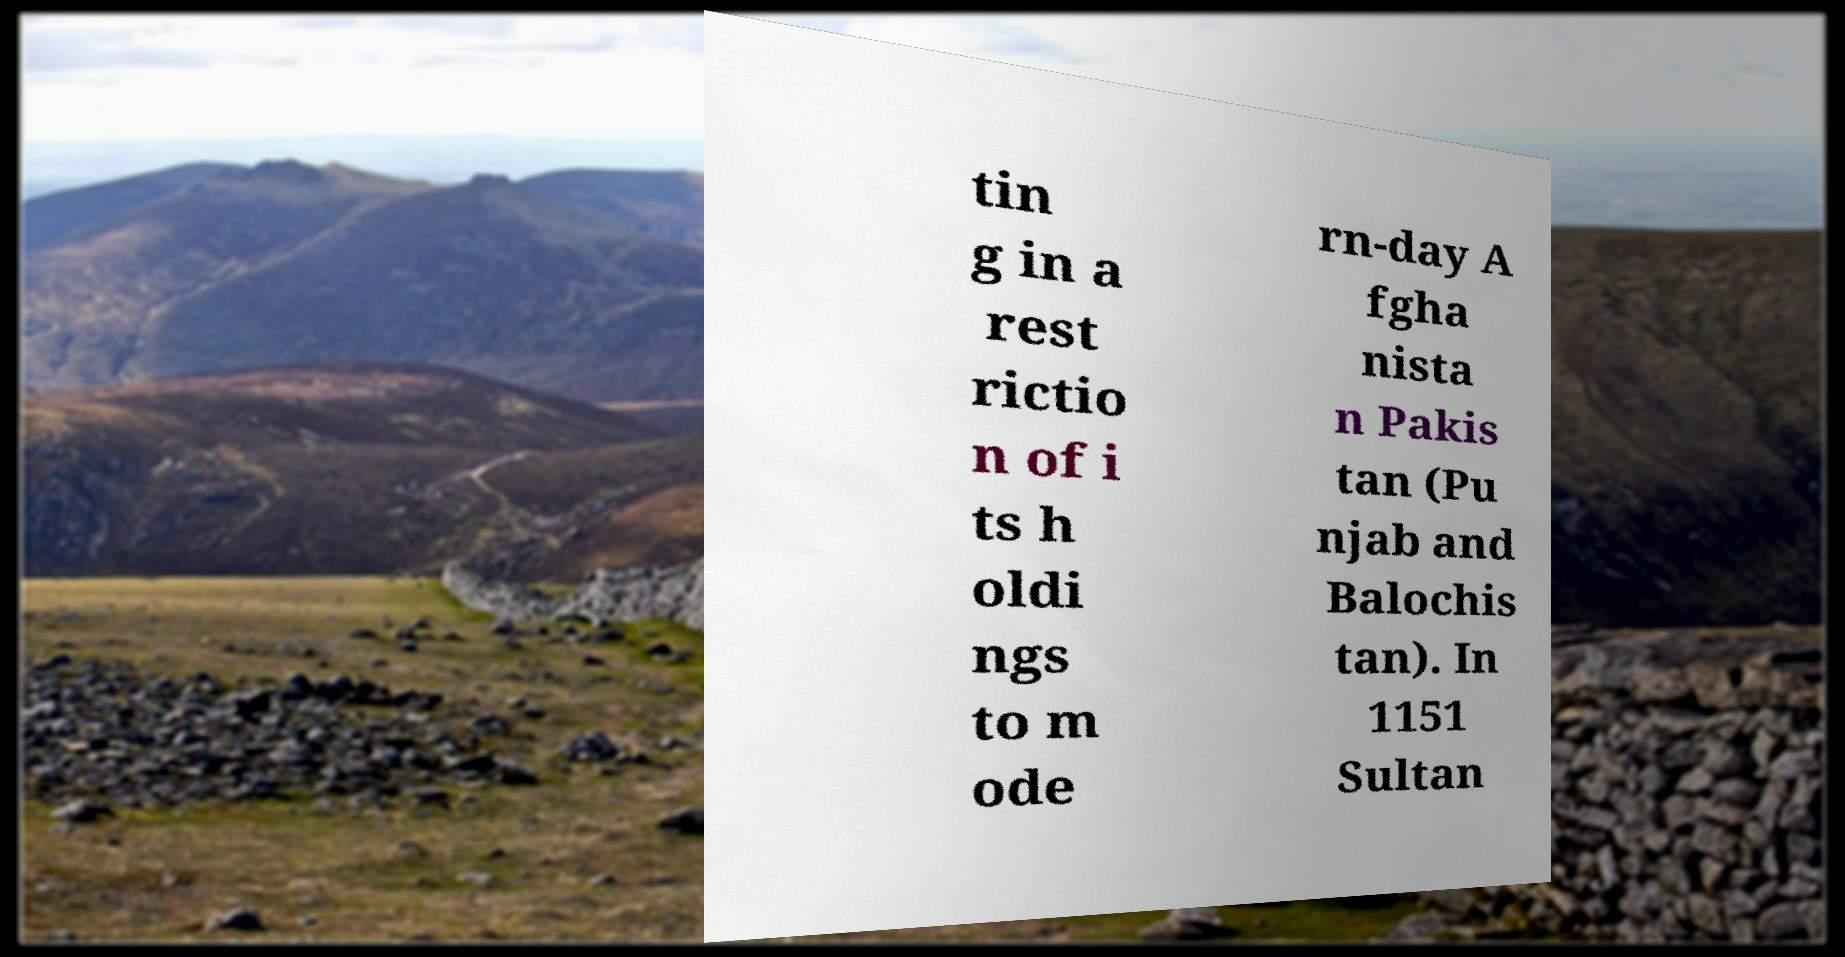Can you read and provide the text displayed in the image?This photo seems to have some interesting text. Can you extract and type it out for me? tin g in a rest rictio n of i ts h oldi ngs to m ode rn-day A fgha nista n Pakis tan (Pu njab and Balochis tan). In 1151 Sultan 